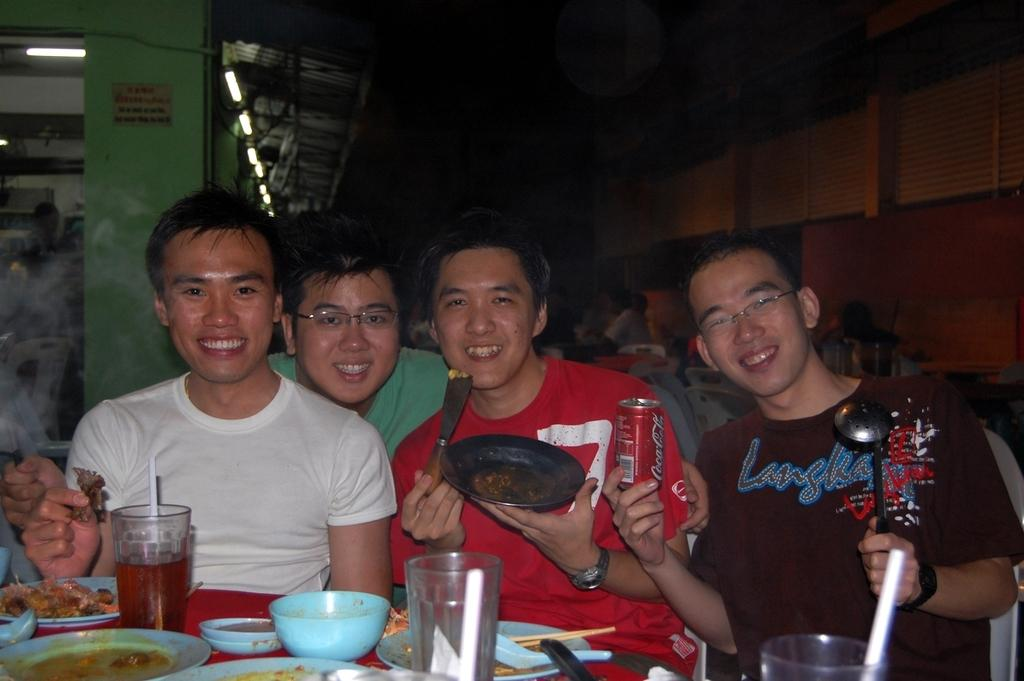What are the men in the image doing? The men are sitting in the image. What objects are on the table in the image? There are plates and glasses on the table in the image. How do the men appear to be feeling in the image? The men have smiles on their faces, indicating that they are happy or enjoying themselves. How much money is being exchanged between the men in the image? There is no indication of money or any financial transaction in the image. What type of bird is sitting on the shoulder of one of the men in the image? There are no birds, including crows, present in the image. 